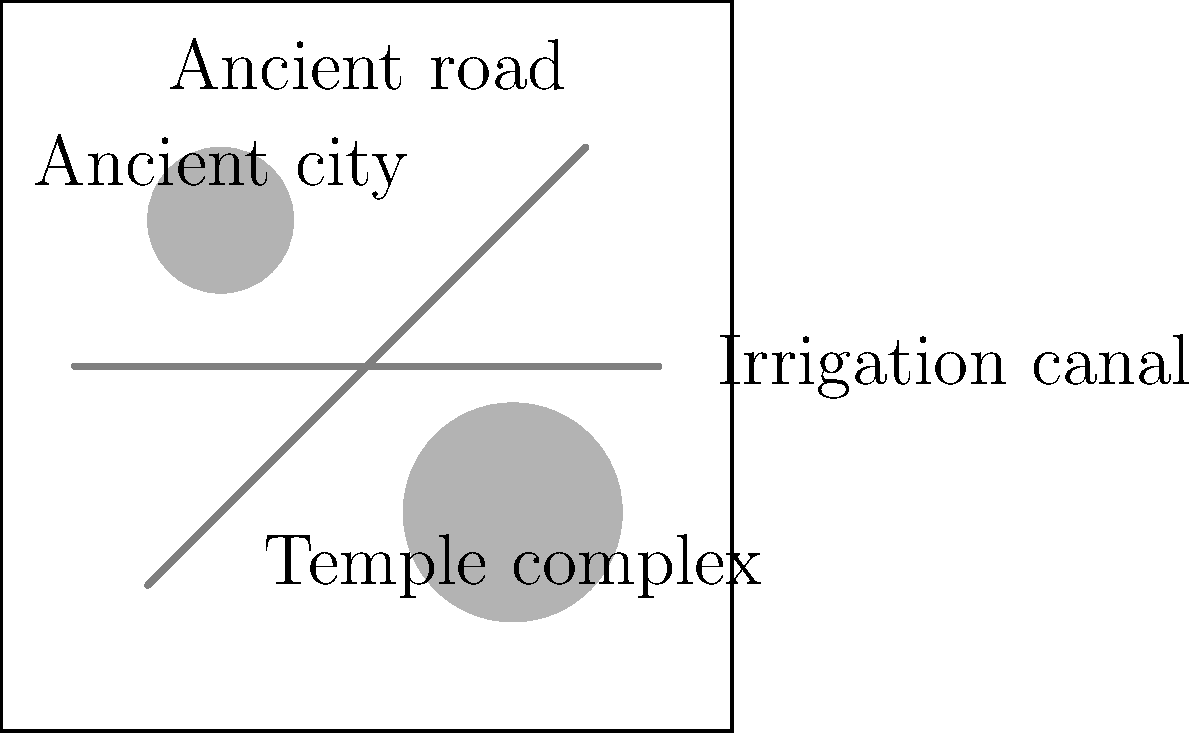Based on the satellite imagery shown, which archaeological feature would likely require the most extensive ground-based verification and excavation to fully understand its historical significance and function? To answer this question, we need to consider the characteristics of each archaeological feature visible in the satellite image:

1. Ancient city: Represented by a small circular area, indicating a concentrated settlement.
2. Temple complex: Shown as a larger circular area, suggesting a more extensive site.
3. Ancient road: Depicted as a diagonal line, indicating a long, linear structure.
4. Irrigation canal: Represented by a horizontal line, showing another linear structure.

Step-by-step analysis:
1. The ancient road and irrigation canal are linear structures that can be relatively easily traced and mapped from satellite imagery. While they require some ground verification, their extent and direction are clear from above.

2. The ancient city, while important, is a smaller concentrated area. It would require detailed excavation, but its boundaries are more defined from the satellite view.

3. The temple complex is the largest circular area in the image, indicating a substantial site. Temple complexes often have multiple structures, layers of construction, and intricate details that are not easily discernible from satellite imagery alone.

4. Temple complexes in the Middle East can span different historical periods, with newer structures built upon older ones, creating a complex stratigraphy that requires careful excavation and analysis.

5. Religious sites often contain valuable artifacts, inscriptions, and architectural features that need detailed in-person examination to understand their cultural and historical context fully.

Given these factors, the temple complex would likely require the most extensive ground-based verification and excavation. Its size, potential complexity, and historical/religious significance make it the most challenging feature to fully understand solely from satellite imagery.
Answer: Temple complex 